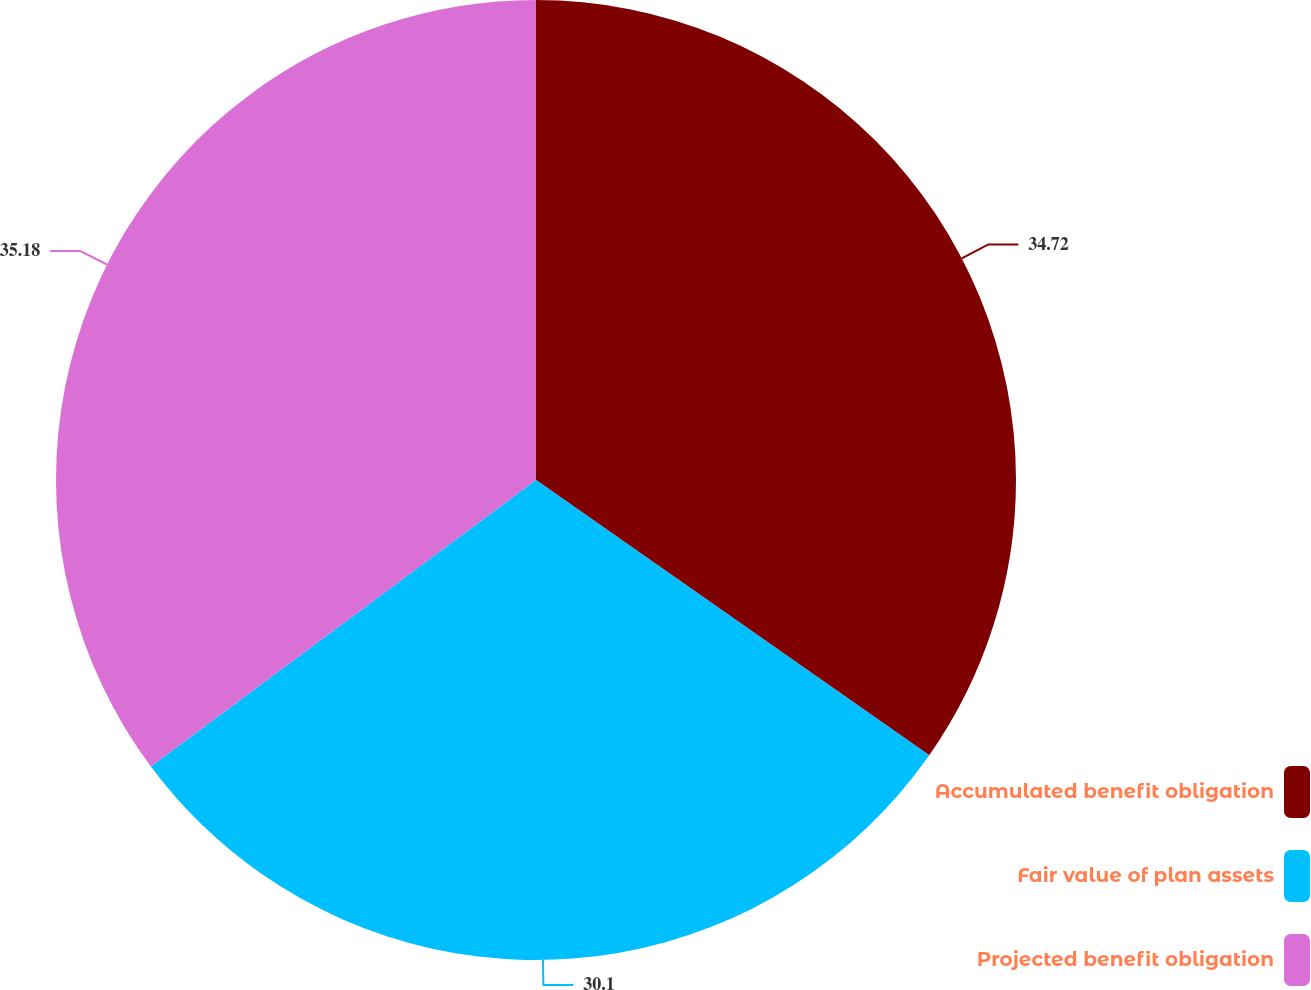Convert chart to OTSL. <chart><loc_0><loc_0><loc_500><loc_500><pie_chart><fcel>Accumulated benefit obligation<fcel>Fair value of plan assets<fcel>Projected benefit obligation<nl><fcel>34.72%<fcel>30.1%<fcel>35.18%<nl></chart> 